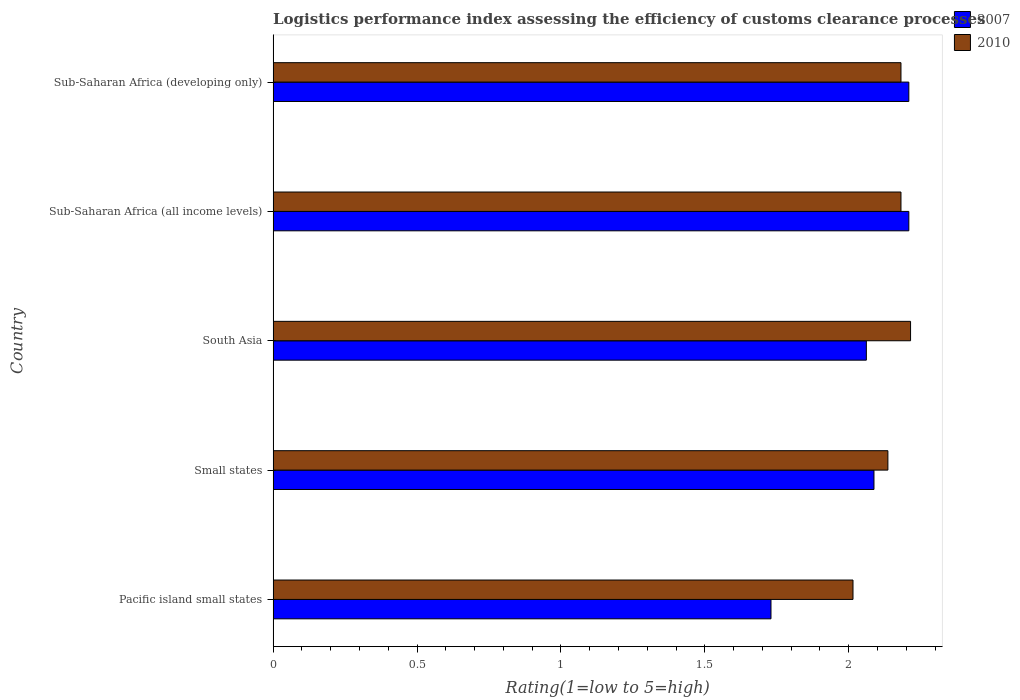How many different coloured bars are there?
Offer a very short reply. 2. Are the number of bars per tick equal to the number of legend labels?
Provide a succinct answer. Yes. What is the label of the 2nd group of bars from the top?
Your answer should be very brief. Sub-Saharan Africa (all income levels). What is the Logistic performance index in 2010 in Sub-Saharan Africa (developing only)?
Keep it short and to the point. 2.18. Across all countries, what is the maximum Logistic performance index in 2010?
Your response must be concise. 2.21. Across all countries, what is the minimum Logistic performance index in 2007?
Ensure brevity in your answer.  1.73. In which country was the Logistic performance index in 2007 maximum?
Ensure brevity in your answer.  Sub-Saharan Africa (all income levels). In which country was the Logistic performance index in 2010 minimum?
Offer a very short reply. Pacific island small states. What is the total Logistic performance index in 2010 in the graph?
Your response must be concise. 10.73. What is the difference between the Logistic performance index in 2010 in South Asia and that in Sub-Saharan Africa (developing only)?
Your answer should be very brief. 0.03. What is the difference between the Logistic performance index in 2007 in Small states and the Logistic performance index in 2010 in Sub-Saharan Africa (developing only)?
Your response must be concise. -0.09. What is the average Logistic performance index in 2010 per country?
Make the answer very short. 2.15. What is the difference between the Logistic performance index in 2007 and Logistic performance index in 2010 in Sub-Saharan Africa (all income levels)?
Provide a succinct answer. 0.03. In how many countries, is the Logistic performance index in 2007 greater than 2.1 ?
Keep it short and to the point. 2. What is the ratio of the Logistic performance index in 2007 in Small states to that in Sub-Saharan Africa (developing only)?
Offer a terse response. 0.95. Is the Logistic performance index in 2007 in Small states less than that in South Asia?
Offer a terse response. No. Is the difference between the Logistic performance index in 2007 in Small states and Sub-Saharan Africa (developing only) greater than the difference between the Logistic performance index in 2010 in Small states and Sub-Saharan Africa (developing only)?
Your answer should be compact. No. What is the difference between the highest and the second highest Logistic performance index in 2010?
Offer a terse response. 0.03. What is the difference between the highest and the lowest Logistic performance index in 2010?
Your answer should be compact. 0.2. In how many countries, is the Logistic performance index in 2010 greater than the average Logistic performance index in 2010 taken over all countries?
Make the answer very short. 3. Is the sum of the Logistic performance index in 2010 in Pacific island small states and South Asia greater than the maximum Logistic performance index in 2007 across all countries?
Offer a terse response. Yes. What does the 2nd bar from the bottom in Sub-Saharan Africa (all income levels) represents?
Provide a short and direct response. 2010. How many countries are there in the graph?
Provide a short and direct response. 5. Does the graph contain grids?
Your response must be concise. No. How are the legend labels stacked?
Provide a short and direct response. Vertical. What is the title of the graph?
Your answer should be very brief. Logistics performance index assessing the efficiency of customs clearance processes. Does "2012" appear as one of the legend labels in the graph?
Your response must be concise. No. What is the label or title of the X-axis?
Offer a very short reply. Rating(1=low to 5=high). What is the label or title of the Y-axis?
Your answer should be very brief. Country. What is the Rating(1=low to 5=high) of 2007 in Pacific island small states?
Your answer should be compact. 1.73. What is the Rating(1=low to 5=high) in 2010 in Pacific island small states?
Give a very brief answer. 2.02. What is the Rating(1=low to 5=high) in 2007 in Small states?
Provide a succinct answer. 2.09. What is the Rating(1=low to 5=high) in 2010 in Small states?
Your answer should be very brief. 2.14. What is the Rating(1=low to 5=high) in 2007 in South Asia?
Offer a very short reply. 2.06. What is the Rating(1=low to 5=high) of 2010 in South Asia?
Your answer should be compact. 2.21. What is the Rating(1=low to 5=high) of 2007 in Sub-Saharan Africa (all income levels)?
Your response must be concise. 2.21. What is the Rating(1=low to 5=high) of 2010 in Sub-Saharan Africa (all income levels)?
Offer a terse response. 2.18. What is the Rating(1=low to 5=high) in 2007 in Sub-Saharan Africa (developing only)?
Offer a terse response. 2.21. What is the Rating(1=low to 5=high) of 2010 in Sub-Saharan Africa (developing only)?
Keep it short and to the point. 2.18. Across all countries, what is the maximum Rating(1=low to 5=high) in 2007?
Make the answer very short. 2.21. Across all countries, what is the maximum Rating(1=low to 5=high) of 2010?
Offer a very short reply. 2.21. Across all countries, what is the minimum Rating(1=low to 5=high) in 2007?
Make the answer very short. 1.73. Across all countries, what is the minimum Rating(1=low to 5=high) in 2010?
Offer a very short reply. 2.02. What is the total Rating(1=low to 5=high) of 2007 in the graph?
Your answer should be very brief. 10.3. What is the total Rating(1=low to 5=high) in 2010 in the graph?
Your answer should be very brief. 10.73. What is the difference between the Rating(1=low to 5=high) in 2007 in Pacific island small states and that in Small states?
Ensure brevity in your answer.  -0.36. What is the difference between the Rating(1=low to 5=high) of 2010 in Pacific island small states and that in Small states?
Keep it short and to the point. -0.12. What is the difference between the Rating(1=low to 5=high) of 2007 in Pacific island small states and that in South Asia?
Keep it short and to the point. -0.33. What is the difference between the Rating(1=low to 5=high) of 2010 in Pacific island small states and that in South Asia?
Your response must be concise. -0.2. What is the difference between the Rating(1=low to 5=high) in 2007 in Pacific island small states and that in Sub-Saharan Africa (all income levels)?
Offer a very short reply. -0.48. What is the difference between the Rating(1=low to 5=high) in 2007 in Pacific island small states and that in Sub-Saharan Africa (developing only)?
Your response must be concise. -0.48. What is the difference between the Rating(1=low to 5=high) of 2007 in Small states and that in South Asia?
Your response must be concise. 0.03. What is the difference between the Rating(1=low to 5=high) of 2010 in Small states and that in South Asia?
Keep it short and to the point. -0.08. What is the difference between the Rating(1=low to 5=high) in 2007 in Small states and that in Sub-Saharan Africa (all income levels)?
Your answer should be compact. -0.12. What is the difference between the Rating(1=low to 5=high) in 2010 in Small states and that in Sub-Saharan Africa (all income levels)?
Give a very brief answer. -0.05. What is the difference between the Rating(1=low to 5=high) in 2007 in Small states and that in Sub-Saharan Africa (developing only)?
Give a very brief answer. -0.12. What is the difference between the Rating(1=low to 5=high) of 2010 in Small states and that in Sub-Saharan Africa (developing only)?
Ensure brevity in your answer.  -0.05. What is the difference between the Rating(1=low to 5=high) in 2007 in South Asia and that in Sub-Saharan Africa (all income levels)?
Provide a succinct answer. -0.15. What is the difference between the Rating(1=low to 5=high) in 2007 in South Asia and that in Sub-Saharan Africa (developing only)?
Offer a terse response. -0.15. What is the difference between the Rating(1=low to 5=high) in 2007 in Sub-Saharan Africa (all income levels) and that in Sub-Saharan Africa (developing only)?
Give a very brief answer. 0. What is the difference between the Rating(1=low to 5=high) of 2007 in Pacific island small states and the Rating(1=low to 5=high) of 2010 in Small states?
Give a very brief answer. -0.41. What is the difference between the Rating(1=low to 5=high) of 2007 in Pacific island small states and the Rating(1=low to 5=high) of 2010 in South Asia?
Give a very brief answer. -0.48. What is the difference between the Rating(1=low to 5=high) of 2007 in Pacific island small states and the Rating(1=low to 5=high) of 2010 in Sub-Saharan Africa (all income levels)?
Make the answer very short. -0.45. What is the difference between the Rating(1=low to 5=high) of 2007 in Pacific island small states and the Rating(1=low to 5=high) of 2010 in Sub-Saharan Africa (developing only)?
Make the answer very short. -0.45. What is the difference between the Rating(1=low to 5=high) in 2007 in Small states and the Rating(1=low to 5=high) in 2010 in South Asia?
Offer a terse response. -0.13. What is the difference between the Rating(1=low to 5=high) of 2007 in Small states and the Rating(1=low to 5=high) of 2010 in Sub-Saharan Africa (all income levels)?
Provide a succinct answer. -0.09. What is the difference between the Rating(1=low to 5=high) of 2007 in Small states and the Rating(1=low to 5=high) of 2010 in Sub-Saharan Africa (developing only)?
Keep it short and to the point. -0.09. What is the difference between the Rating(1=low to 5=high) of 2007 in South Asia and the Rating(1=low to 5=high) of 2010 in Sub-Saharan Africa (all income levels)?
Provide a succinct answer. -0.12. What is the difference between the Rating(1=low to 5=high) of 2007 in South Asia and the Rating(1=low to 5=high) of 2010 in Sub-Saharan Africa (developing only)?
Provide a succinct answer. -0.12. What is the difference between the Rating(1=low to 5=high) in 2007 in Sub-Saharan Africa (all income levels) and the Rating(1=low to 5=high) in 2010 in Sub-Saharan Africa (developing only)?
Your response must be concise. 0.03. What is the average Rating(1=low to 5=high) in 2007 per country?
Offer a terse response. 2.06. What is the average Rating(1=low to 5=high) in 2010 per country?
Your answer should be very brief. 2.15. What is the difference between the Rating(1=low to 5=high) of 2007 and Rating(1=low to 5=high) of 2010 in Pacific island small states?
Give a very brief answer. -0.28. What is the difference between the Rating(1=low to 5=high) in 2007 and Rating(1=low to 5=high) in 2010 in Small states?
Offer a terse response. -0.05. What is the difference between the Rating(1=low to 5=high) in 2007 and Rating(1=low to 5=high) in 2010 in South Asia?
Your response must be concise. -0.15. What is the difference between the Rating(1=low to 5=high) in 2007 and Rating(1=low to 5=high) in 2010 in Sub-Saharan Africa (all income levels)?
Provide a succinct answer. 0.03. What is the difference between the Rating(1=low to 5=high) of 2007 and Rating(1=low to 5=high) of 2010 in Sub-Saharan Africa (developing only)?
Your response must be concise. 0.03. What is the ratio of the Rating(1=low to 5=high) of 2007 in Pacific island small states to that in Small states?
Give a very brief answer. 0.83. What is the ratio of the Rating(1=low to 5=high) in 2010 in Pacific island small states to that in Small states?
Your answer should be very brief. 0.94. What is the ratio of the Rating(1=low to 5=high) of 2007 in Pacific island small states to that in South Asia?
Offer a terse response. 0.84. What is the ratio of the Rating(1=low to 5=high) of 2010 in Pacific island small states to that in South Asia?
Give a very brief answer. 0.91. What is the ratio of the Rating(1=low to 5=high) in 2007 in Pacific island small states to that in Sub-Saharan Africa (all income levels)?
Give a very brief answer. 0.78. What is the ratio of the Rating(1=low to 5=high) of 2010 in Pacific island small states to that in Sub-Saharan Africa (all income levels)?
Make the answer very short. 0.92. What is the ratio of the Rating(1=low to 5=high) of 2007 in Pacific island small states to that in Sub-Saharan Africa (developing only)?
Offer a very short reply. 0.78. What is the ratio of the Rating(1=low to 5=high) of 2010 in Pacific island small states to that in Sub-Saharan Africa (developing only)?
Ensure brevity in your answer.  0.92. What is the ratio of the Rating(1=low to 5=high) in 2007 in Small states to that in South Asia?
Make the answer very short. 1.01. What is the ratio of the Rating(1=low to 5=high) of 2010 in Small states to that in South Asia?
Your answer should be very brief. 0.96. What is the ratio of the Rating(1=low to 5=high) in 2007 in Small states to that in Sub-Saharan Africa (all income levels)?
Give a very brief answer. 0.95. What is the ratio of the Rating(1=low to 5=high) in 2010 in Small states to that in Sub-Saharan Africa (all income levels)?
Offer a terse response. 0.98. What is the ratio of the Rating(1=low to 5=high) of 2007 in Small states to that in Sub-Saharan Africa (developing only)?
Give a very brief answer. 0.95. What is the ratio of the Rating(1=low to 5=high) in 2010 in Small states to that in Sub-Saharan Africa (developing only)?
Your answer should be compact. 0.98. What is the ratio of the Rating(1=low to 5=high) in 2007 in South Asia to that in Sub-Saharan Africa (all income levels)?
Keep it short and to the point. 0.93. What is the ratio of the Rating(1=low to 5=high) of 2010 in South Asia to that in Sub-Saharan Africa (all income levels)?
Ensure brevity in your answer.  1.02. What is the ratio of the Rating(1=low to 5=high) of 2007 in South Asia to that in Sub-Saharan Africa (developing only)?
Make the answer very short. 0.93. What is the ratio of the Rating(1=low to 5=high) in 2010 in South Asia to that in Sub-Saharan Africa (developing only)?
Your answer should be compact. 1.02. What is the ratio of the Rating(1=low to 5=high) of 2007 in Sub-Saharan Africa (all income levels) to that in Sub-Saharan Africa (developing only)?
Provide a succinct answer. 1. What is the ratio of the Rating(1=low to 5=high) in 2010 in Sub-Saharan Africa (all income levels) to that in Sub-Saharan Africa (developing only)?
Keep it short and to the point. 1. What is the difference between the highest and the second highest Rating(1=low to 5=high) of 2007?
Make the answer very short. 0. What is the difference between the highest and the second highest Rating(1=low to 5=high) of 2010?
Keep it short and to the point. 0.03. What is the difference between the highest and the lowest Rating(1=low to 5=high) of 2007?
Keep it short and to the point. 0.48. 